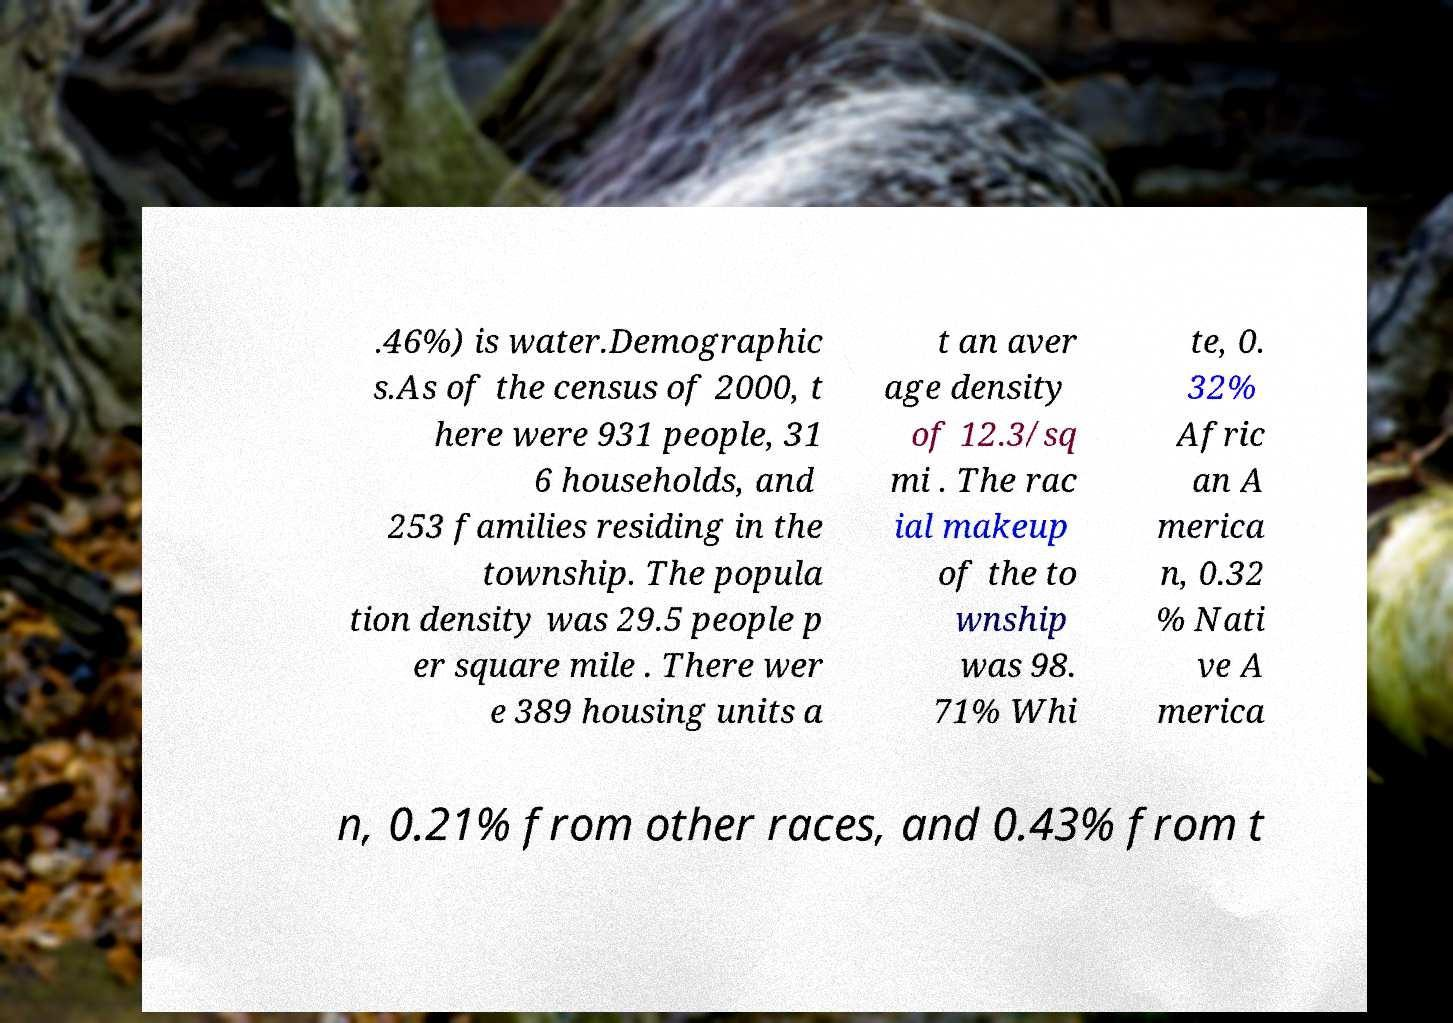For documentation purposes, I need the text within this image transcribed. Could you provide that? .46%) is water.Demographic s.As of the census of 2000, t here were 931 people, 31 6 households, and 253 families residing in the township. The popula tion density was 29.5 people p er square mile . There wer e 389 housing units a t an aver age density of 12.3/sq mi . The rac ial makeup of the to wnship was 98. 71% Whi te, 0. 32% Afric an A merica n, 0.32 % Nati ve A merica n, 0.21% from other races, and 0.43% from t 